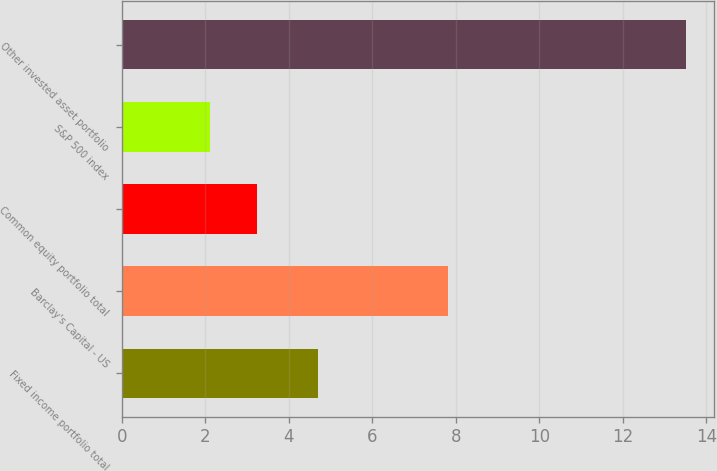<chart> <loc_0><loc_0><loc_500><loc_500><bar_chart><fcel>Fixed income portfolio total<fcel>Barclay's Capital - US<fcel>Common equity portfolio total<fcel>S&P 500 index<fcel>Other invested asset portfolio<nl><fcel>4.7<fcel>7.8<fcel>3.24<fcel>2.1<fcel>13.5<nl></chart> 